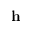Convert formula to latex. <formula><loc_0><loc_0><loc_500><loc_500>h</formula> 